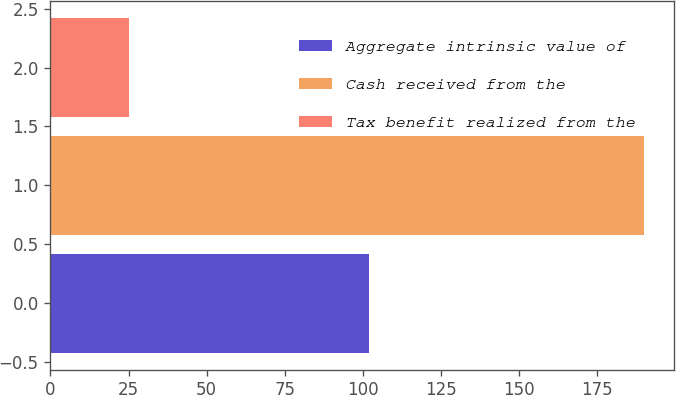Convert chart. <chart><loc_0><loc_0><loc_500><loc_500><bar_chart><fcel>Aggregate intrinsic value of<fcel>Cash received from the<fcel>Tax benefit realized from the<nl><fcel>102<fcel>190<fcel>25<nl></chart> 